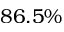<formula> <loc_0><loc_0><loc_500><loc_500>8 6 . 5 \%</formula> 